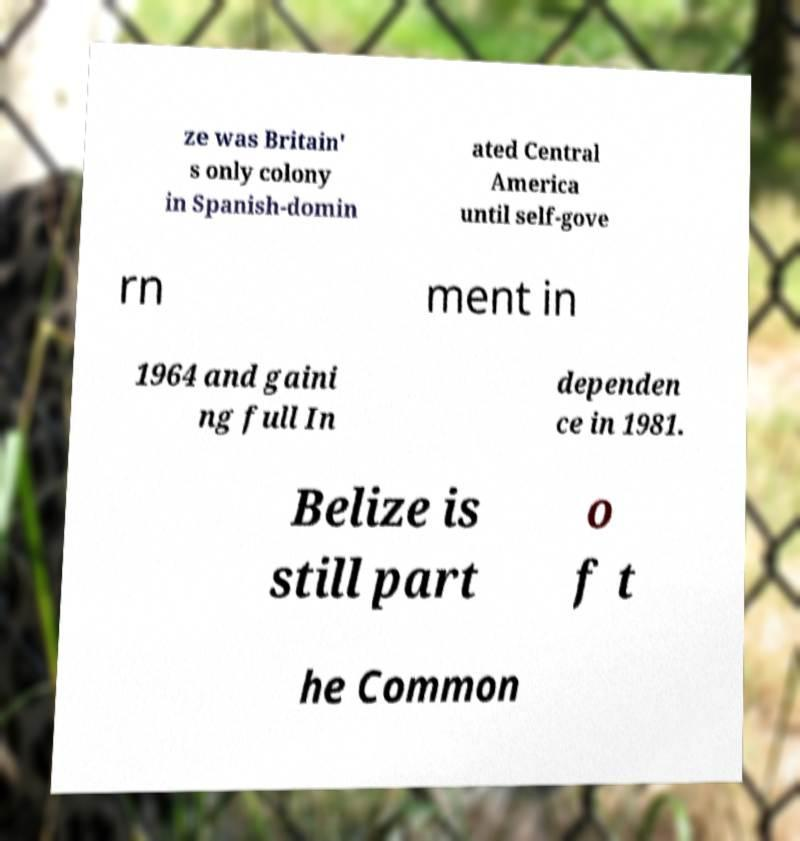For documentation purposes, I need the text within this image transcribed. Could you provide that? ze was Britain' s only colony in Spanish-domin ated Central America until self-gove rn ment in 1964 and gaini ng full In dependen ce in 1981. Belize is still part o f t he Common 